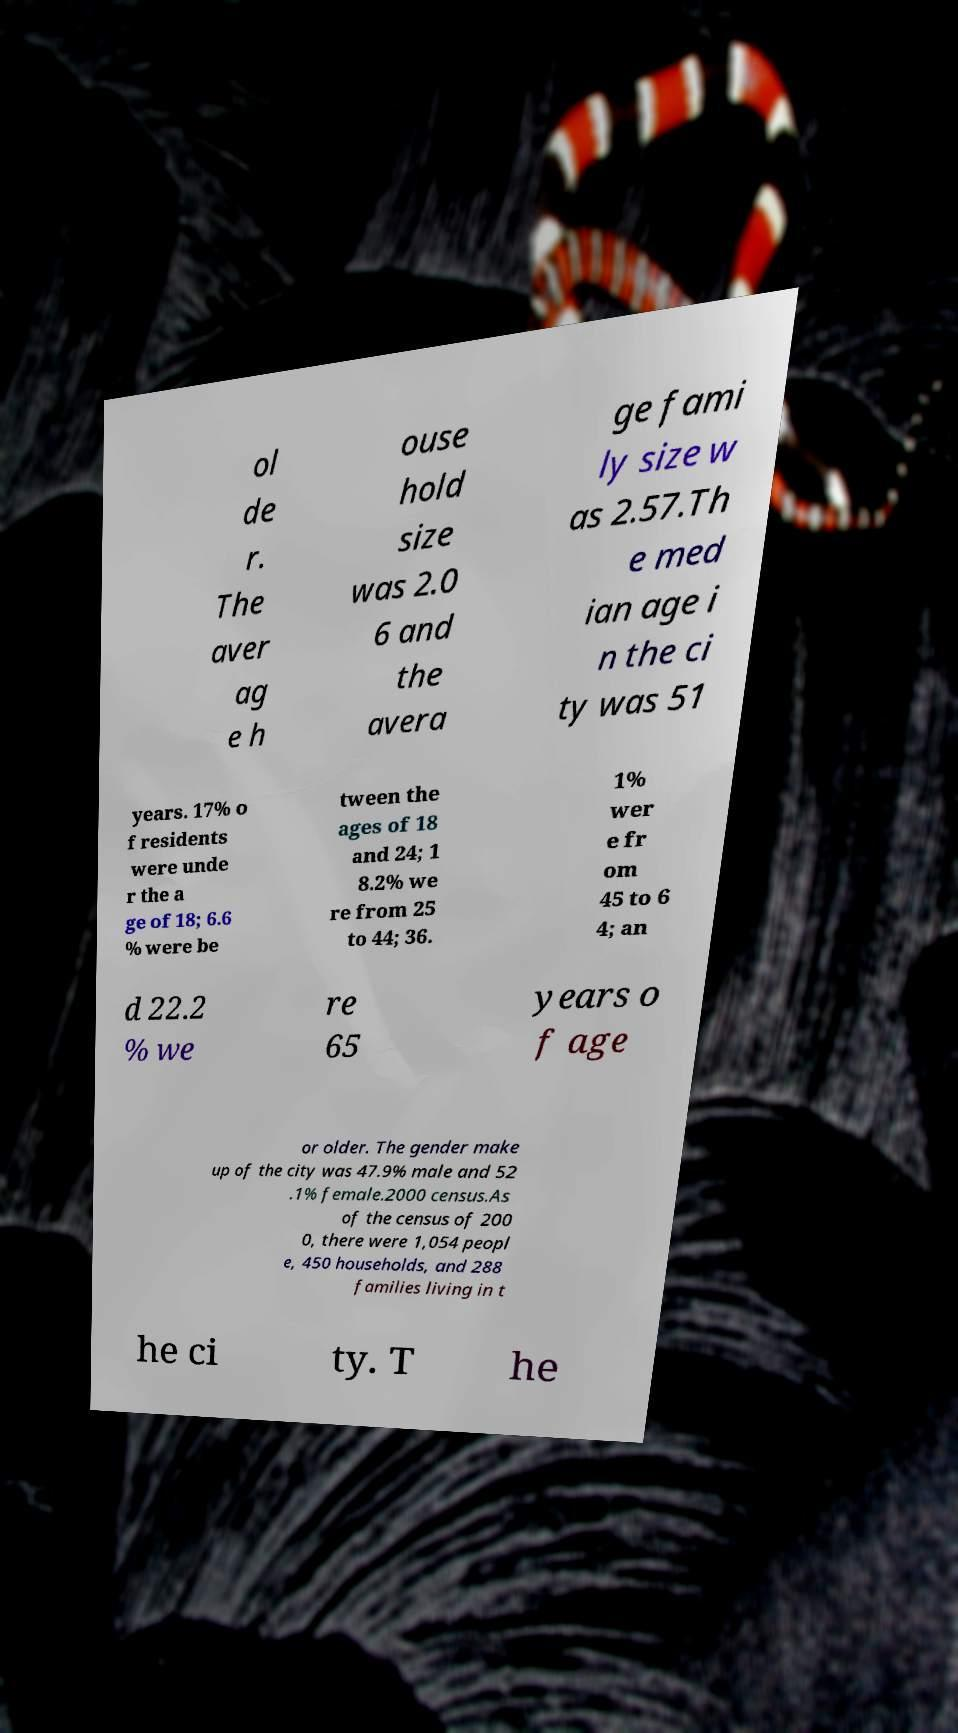Could you assist in decoding the text presented in this image and type it out clearly? ol de r. The aver ag e h ouse hold size was 2.0 6 and the avera ge fami ly size w as 2.57.Th e med ian age i n the ci ty was 51 years. 17% o f residents were unde r the a ge of 18; 6.6 % were be tween the ages of 18 and 24; 1 8.2% we re from 25 to 44; 36. 1% wer e fr om 45 to 6 4; an d 22.2 % we re 65 years o f age or older. The gender make up of the city was 47.9% male and 52 .1% female.2000 census.As of the census of 200 0, there were 1,054 peopl e, 450 households, and 288 families living in t he ci ty. T he 